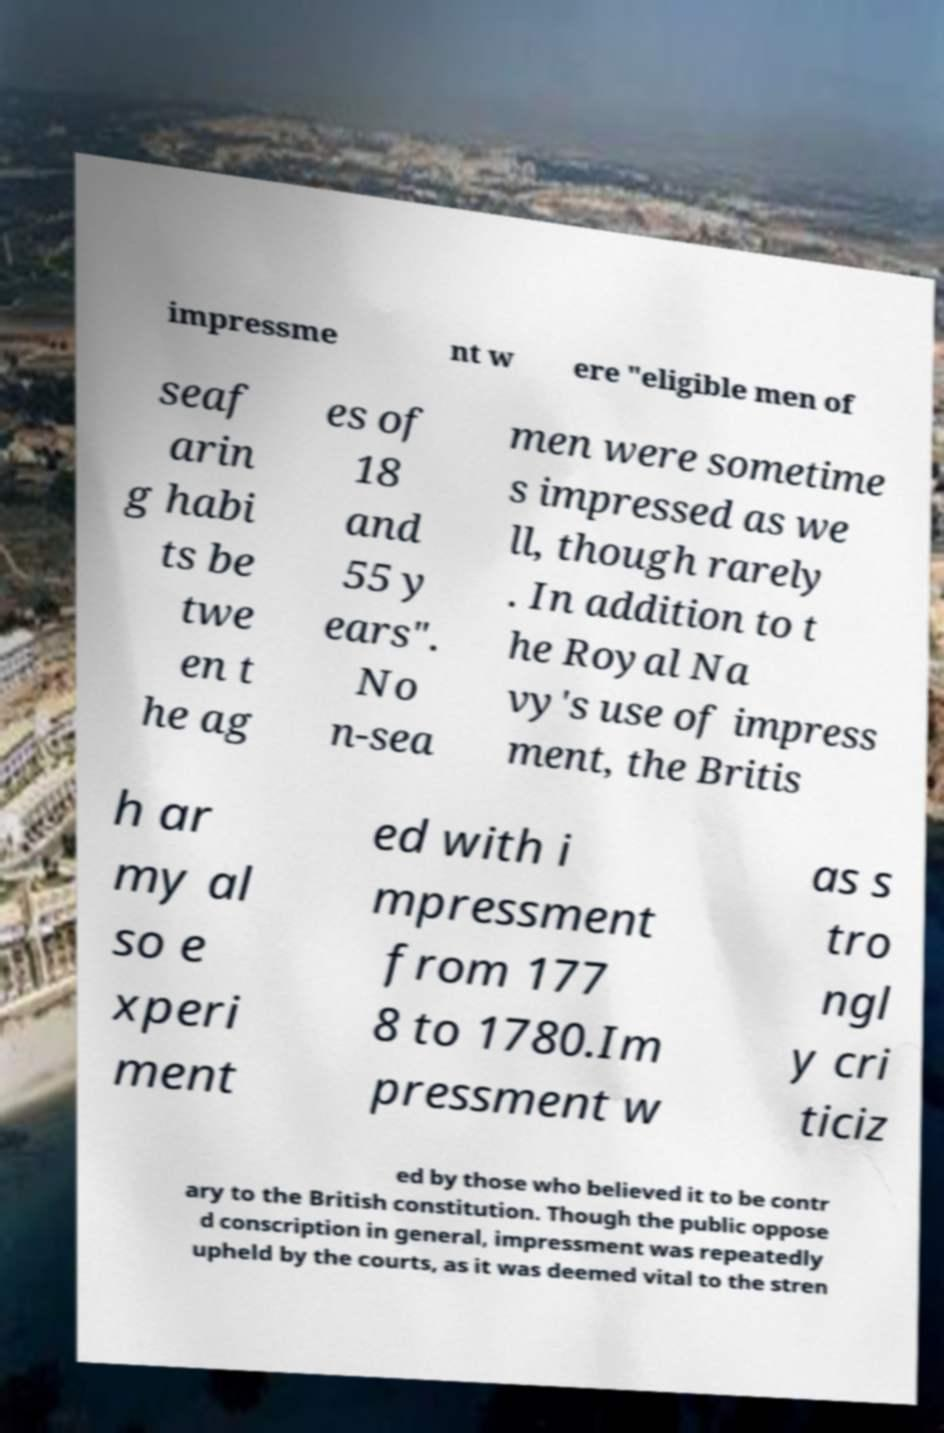Can you read and provide the text displayed in the image?This photo seems to have some interesting text. Can you extract and type it out for me? impressme nt w ere "eligible men of seaf arin g habi ts be twe en t he ag es of 18 and 55 y ears". No n-sea men were sometime s impressed as we ll, though rarely . In addition to t he Royal Na vy's use of impress ment, the Britis h ar my al so e xperi ment ed with i mpressment from 177 8 to 1780.Im pressment w as s tro ngl y cri ticiz ed by those who believed it to be contr ary to the British constitution. Though the public oppose d conscription in general, impressment was repeatedly upheld by the courts, as it was deemed vital to the stren 